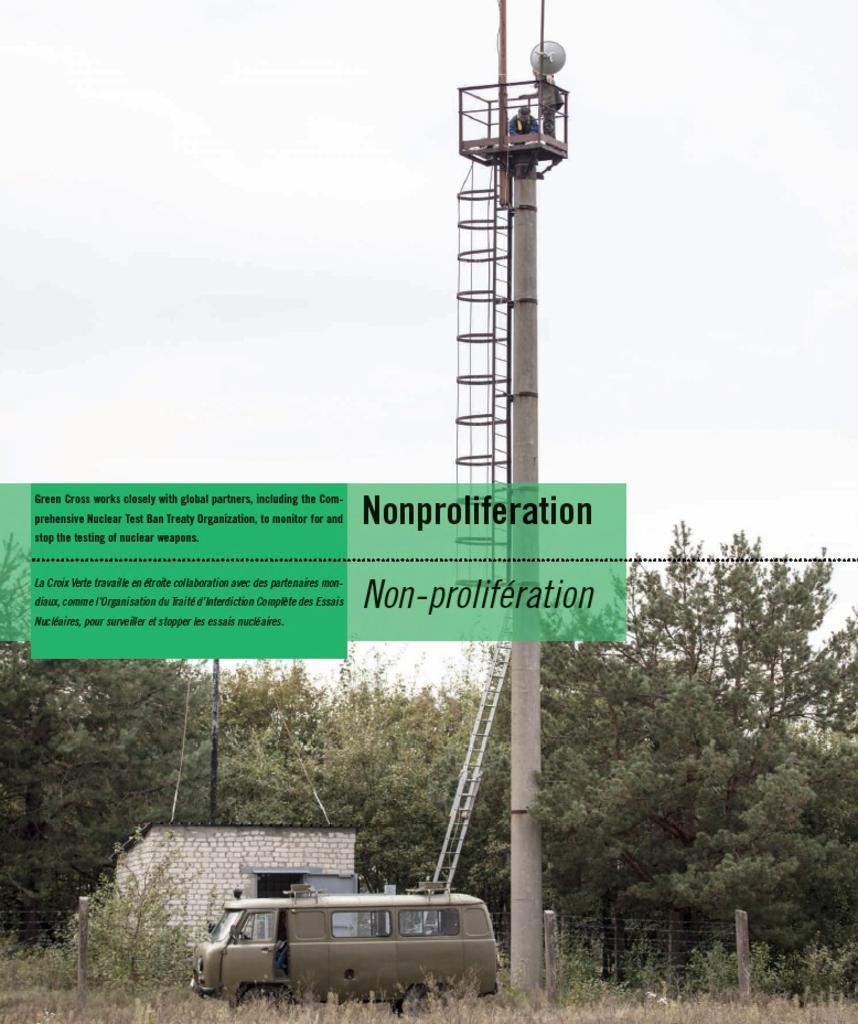Can you describe this image briefly? This picture is clicked outside. In the foreground we can see a vehicle, metal rods, ladder and a pole and we can see the grass, plants and trees and a shed and we can see there are some objects placed on the ground. In the center we can see the text on the image. In the background we can see the sky. At the top we can see the person and some other objects. 